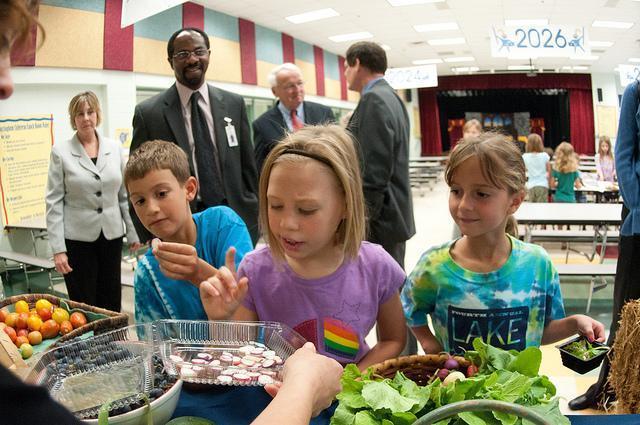How many bowls are there?
Give a very brief answer. 3. How many people are in the photo?
Give a very brief answer. 9. How many banana stems without bananas are there?
Give a very brief answer. 0. 